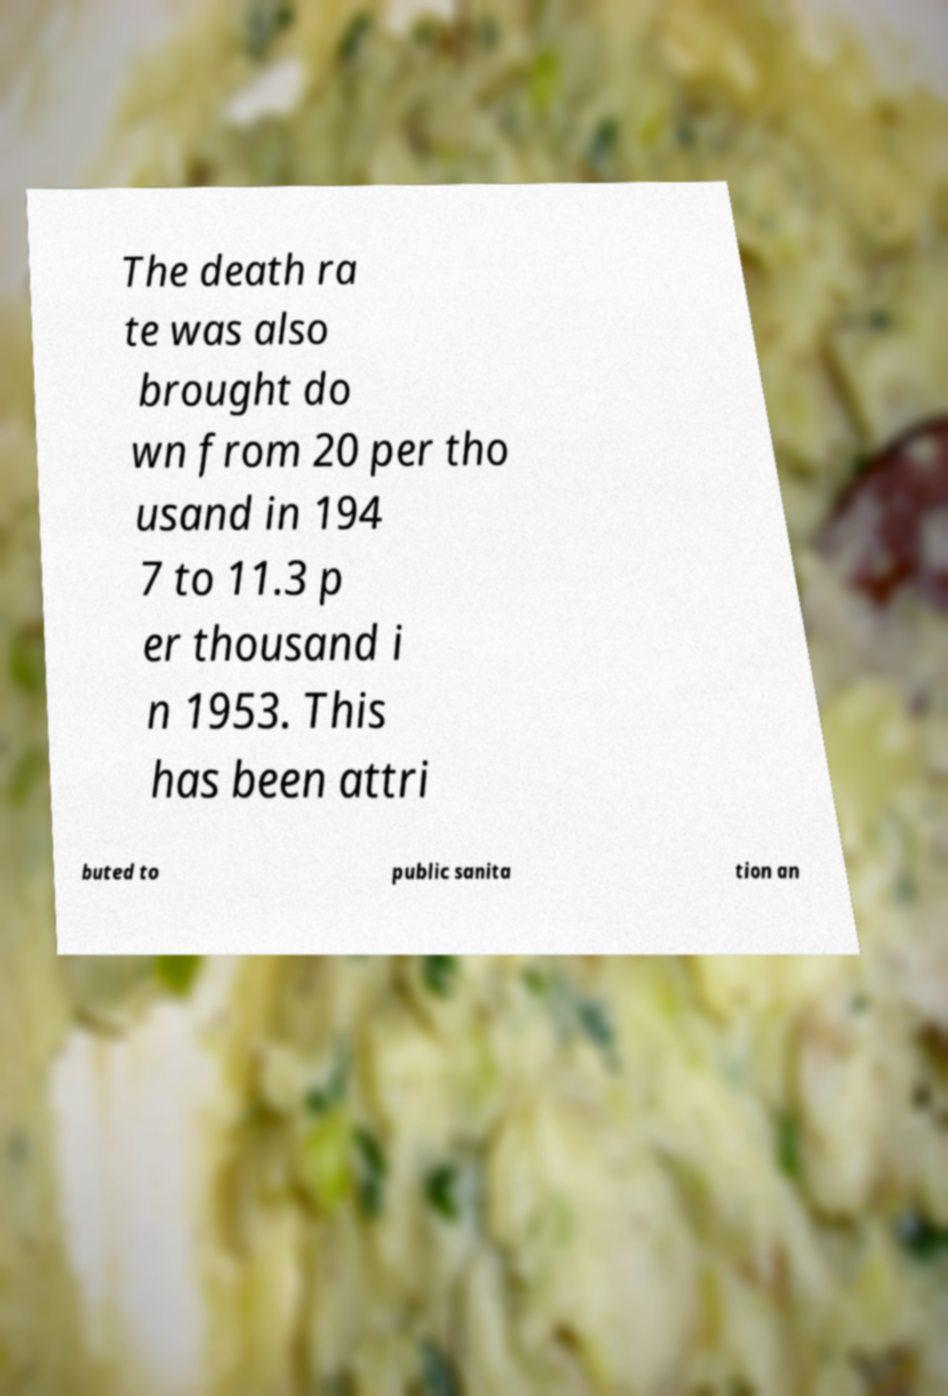Can you accurately transcribe the text from the provided image for me? The death ra te was also brought do wn from 20 per tho usand in 194 7 to 11.3 p er thousand i n 1953. This has been attri buted to public sanita tion an 